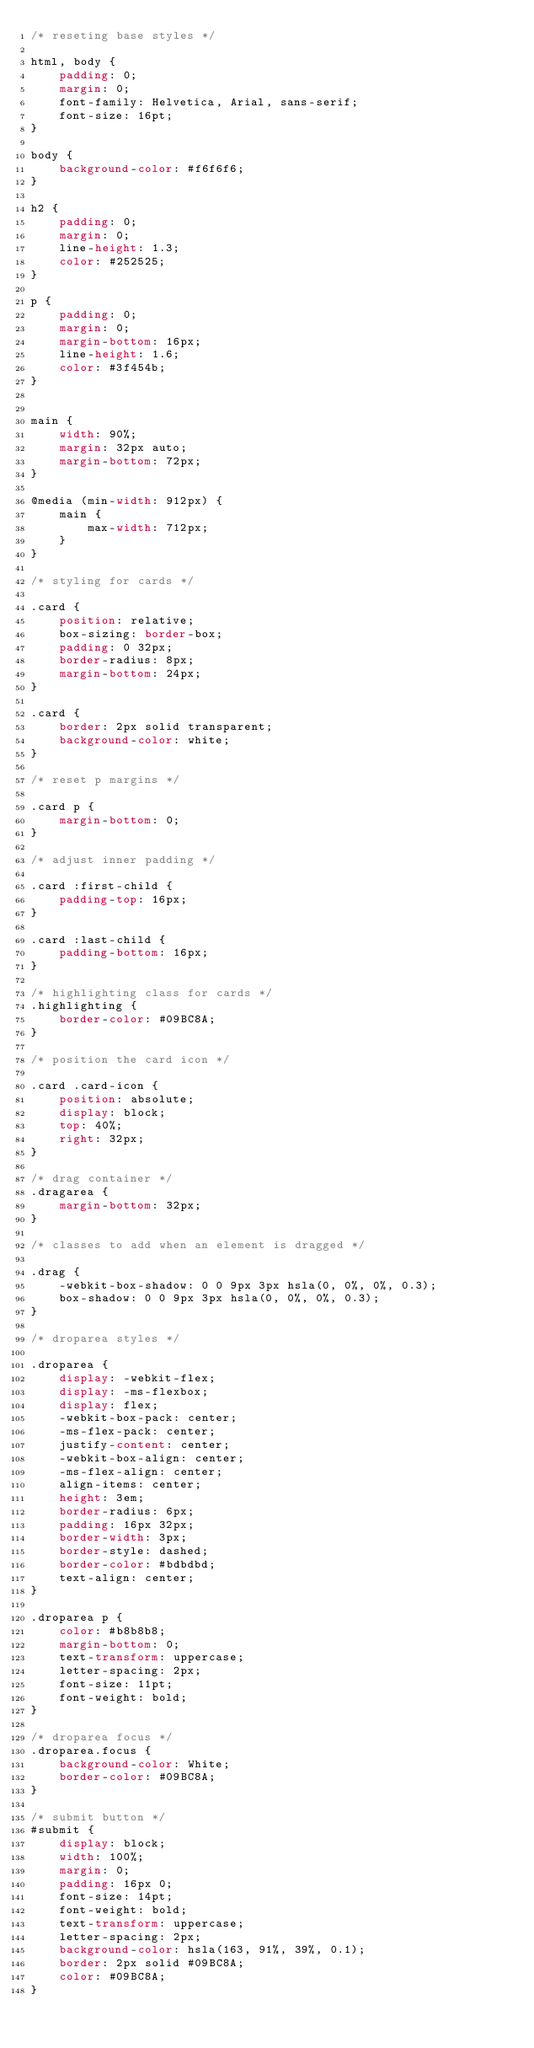Convert code to text. <code><loc_0><loc_0><loc_500><loc_500><_CSS_>/* reseting base styles */

html, body {
    padding: 0;
    margin: 0;
    font-family: Helvetica, Arial, sans-serif;
    font-size: 16pt;
}

body {
    background-color: #f6f6f6;
}

h2 {
    padding: 0;
    margin: 0;
    line-height: 1.3;
    color: #252525;
}

p {
    padding: 0;
    margin: 0;
    margin-bottom: 16px;
    line-height: 1.6;
    color: #3f454b;
}


main {
    width: 90%;
    margin: 32px auto;
    margin-bottom: 72px;
}

@media (min-width: 912px) {
    main {
        max-width: 712px;
    }
}

/* styling for cards */

.card {
    position: relative;
    box-sizing: border-box;
    padding: 0 32px;
    border-radius: 8px;
    margin-bottom: 24px;
}

.card {
    border: 2px solid transparent;
    background-color: white;
}

/* reset p margins */

.card p {
    margin-bottom: 0;
}

/* adjust inner padding */

.card :first-child {
    padding-top: 16px;
}

.card :last-child {
    padding-bottom: 16px;
}

/* highlighting class for cards */
.highlighting {
    border-color: #09BC8A;
}

/* position the card icon */

.card .card-icon {
    position: absolute;
    display: block;
    top: 40%;
    right: 32px;
}

/* drag container */
.dragarea {
    margin-bottom: 32px;
}

/* classes to add when an element is dragged */

.drag {
    -webkit-box-shadow: 0 0 9px 3px hsla(0, 0%, 0%, 0.3);
    box-shadow: 0 0 9px 3px hsla(0, 0%, 0%, 0.3);
}

/* droparea styles */

.droparea {
    display: -webkit-flex;
    display: -ms-flexbox;
    display: flex;
    -webkit-box-pack: center;
    -ms-flex-pack: center;
    justify-content: center;
    -webkit-box-align: center;
    -ms-flex-align: center;
    align-items: center;
    height: 3em;
    border-radius: 6px;
    padding: 16px 32px;
    border-width: 3px;
    border-style: dashed;
    border-color: #bdbdbd;
    text-align: center;
}

.droparea p {
    color: #b8b8b8;
    margin-bottom: 0;
    text-transform: uppercase;
    letter-spacing: 2px;
    font-size: 11pt;
    font-weight: bold;
}

/* droparea focus */
.droparea.focus {
    background-color: White;
    border-color: #09BC8A;
}

/* submit button */
#submit {
    display: block;
    width: 100%;
    margin: 0;
    padding: 16px 0;
    font-size: 14pt;
    font-weight: bold;
    text-transform: uppercase;
    letter-spacing: 2px;
    background-color: hsla(163, 91%, 39%, 0.1);
    border: 2px solid #09BC8A;
    color: #09BC8A;
}</code> 